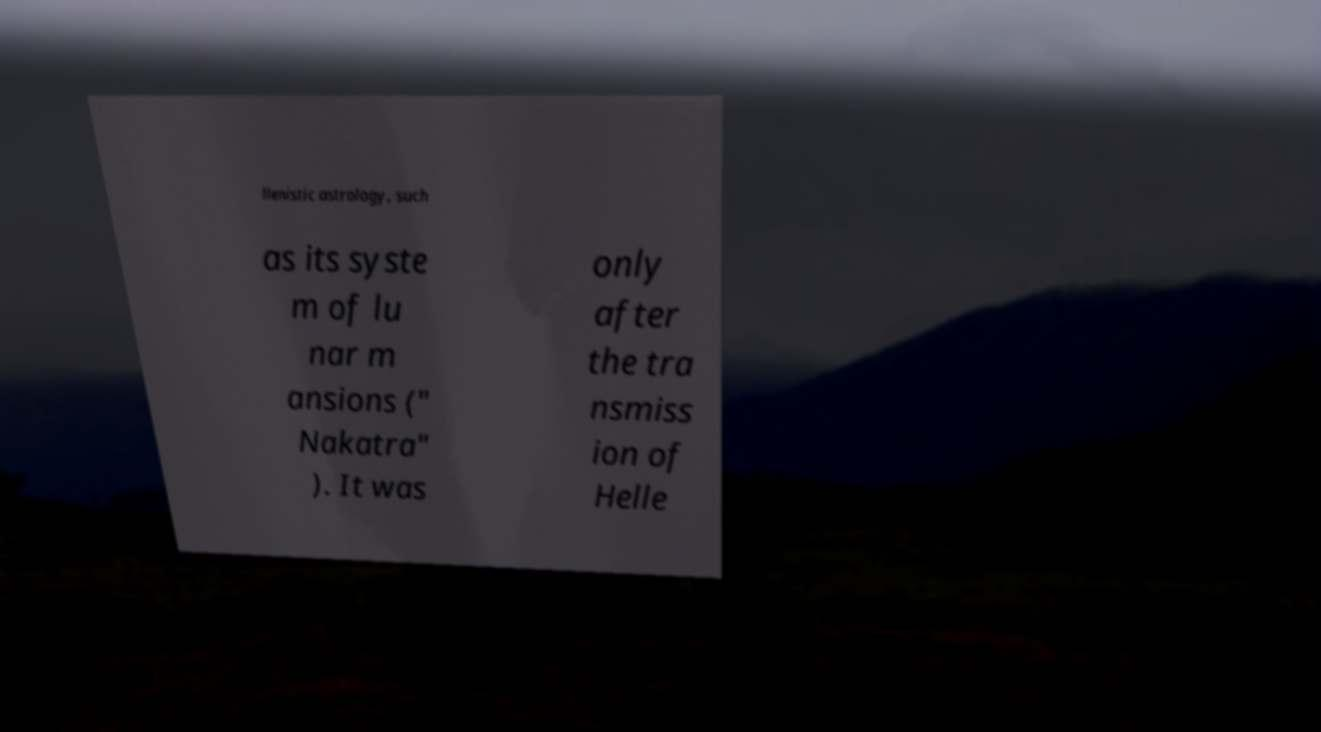There's text embedded in this image that I need extracted. Can you transcribe it verbatim? llenistic astrology, such as its syste m of lu nar m ansions (" Nakatra" ). It was only after the tra nsmiss ion of Helle 